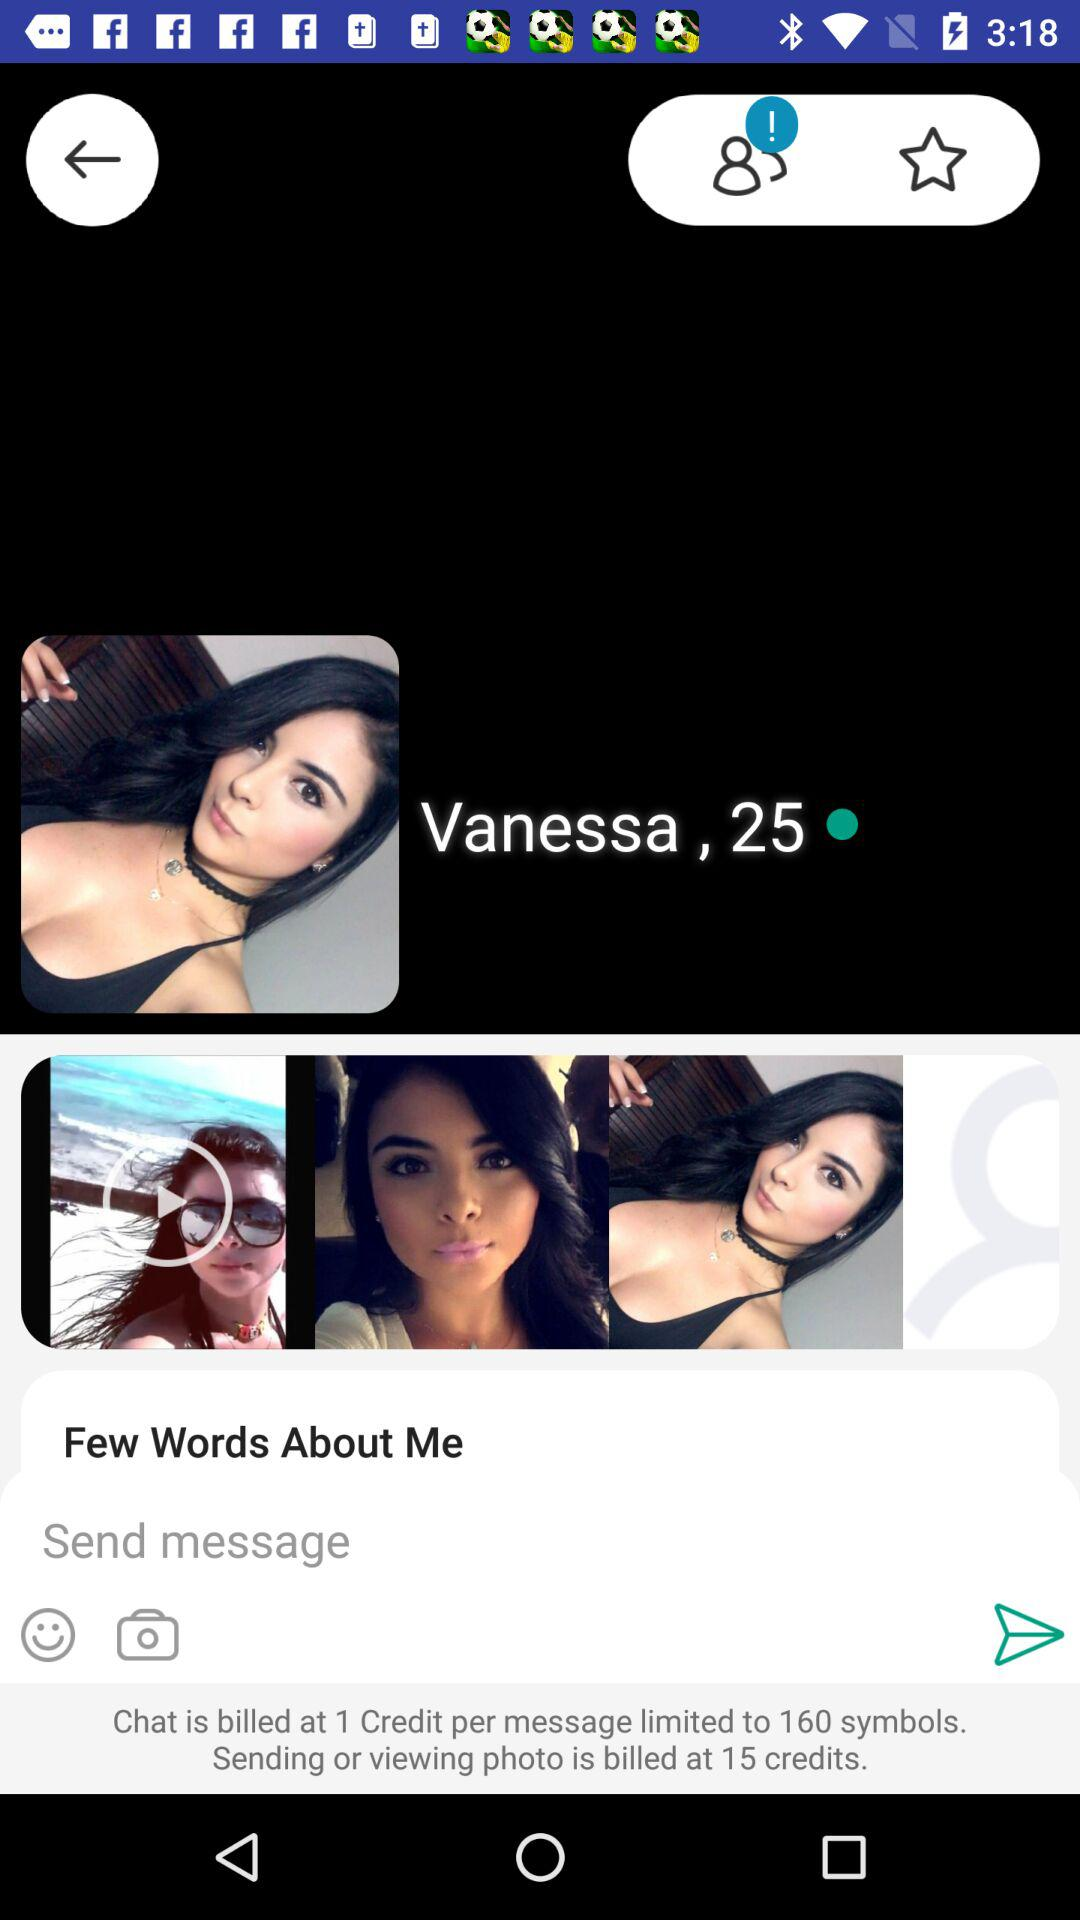How many more credits are required to send a photo than to send a message?
Answer the question using a single word or phrase. 14 